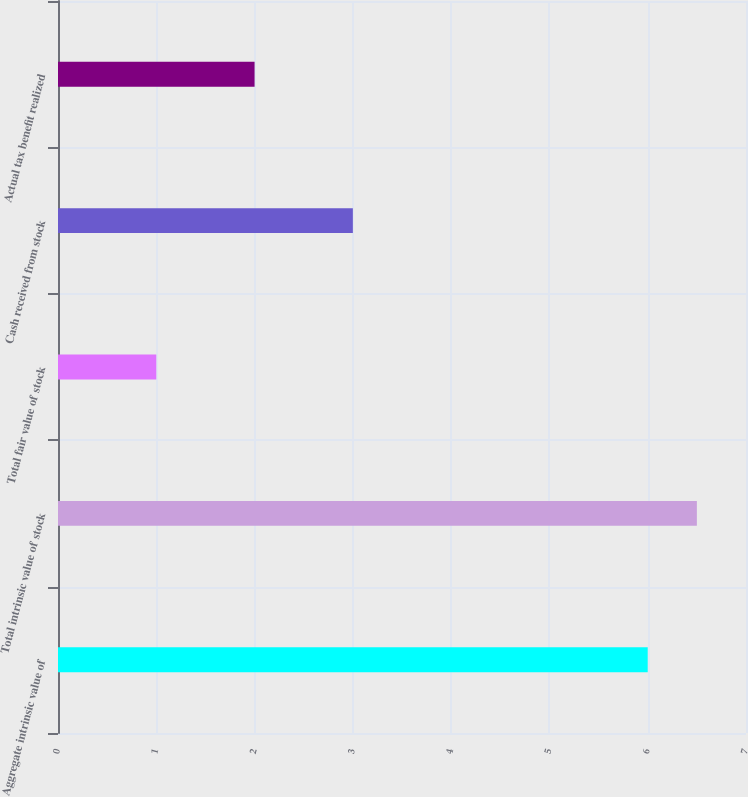Convert chart. <chart><loc_0><loc_0><loc_500><loc_500><bar_chart><fcel>Aggregate intrinsic value of<fcel>Total intrinsic value of stock<fcel>Total fair value of stock<fcel>Cash received from stock<fcel>Actual tax benefit realized<nl><fcel>6<fcel>6.5<fcel>1<fcel>3<fcel>2<nl></chart> 